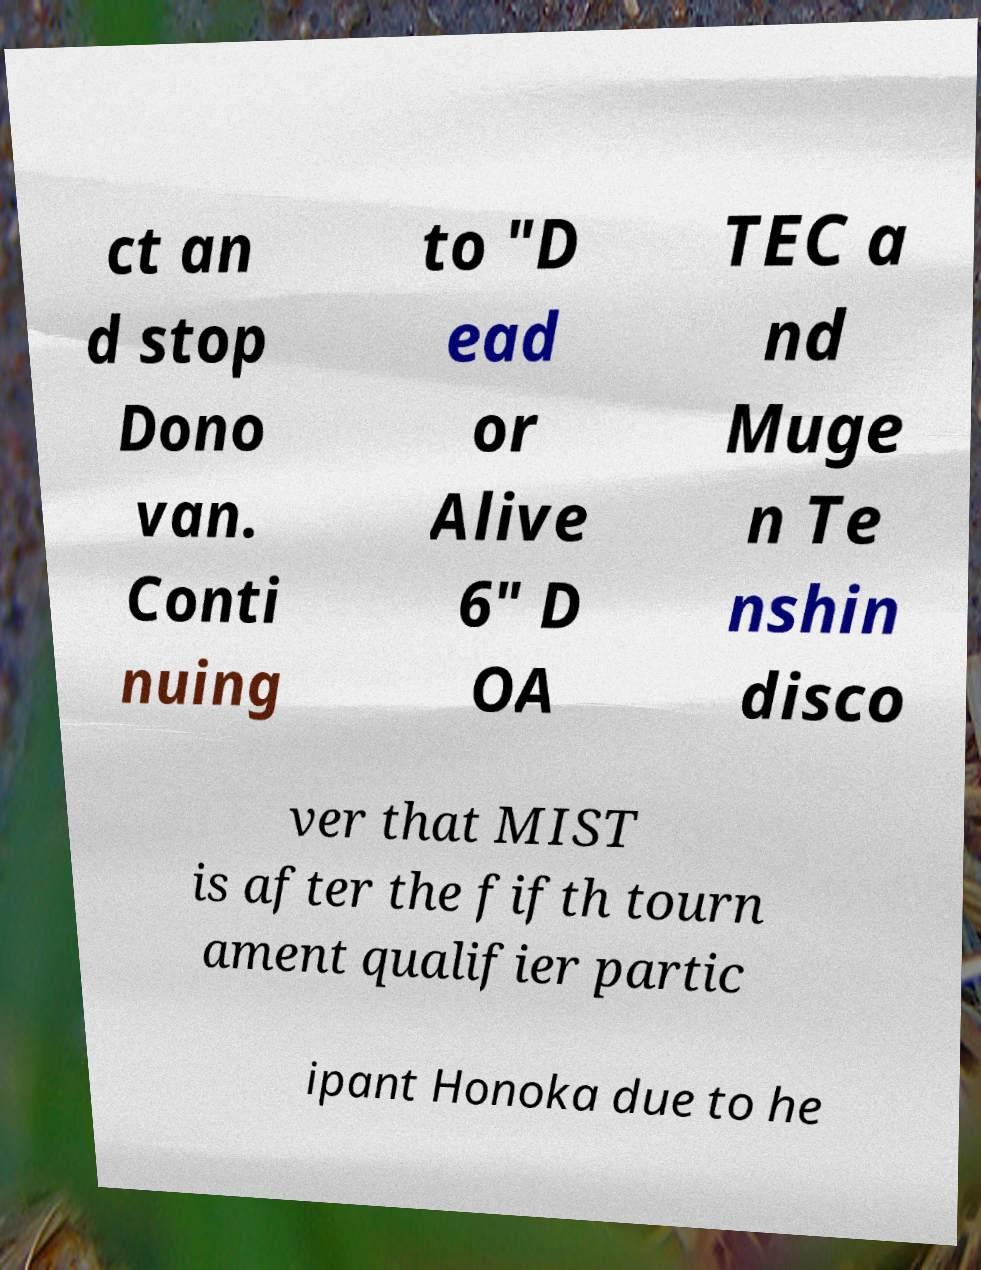Please identify and transcribe the text found in this image. ct an d stop Dono van. Conti nuing to "D ead or Alive 6" D OA TEC a nd Muge n Te nshin disco ver that MIST is after the fifth tourn ament qualifier partic ipant Honoka due to he 